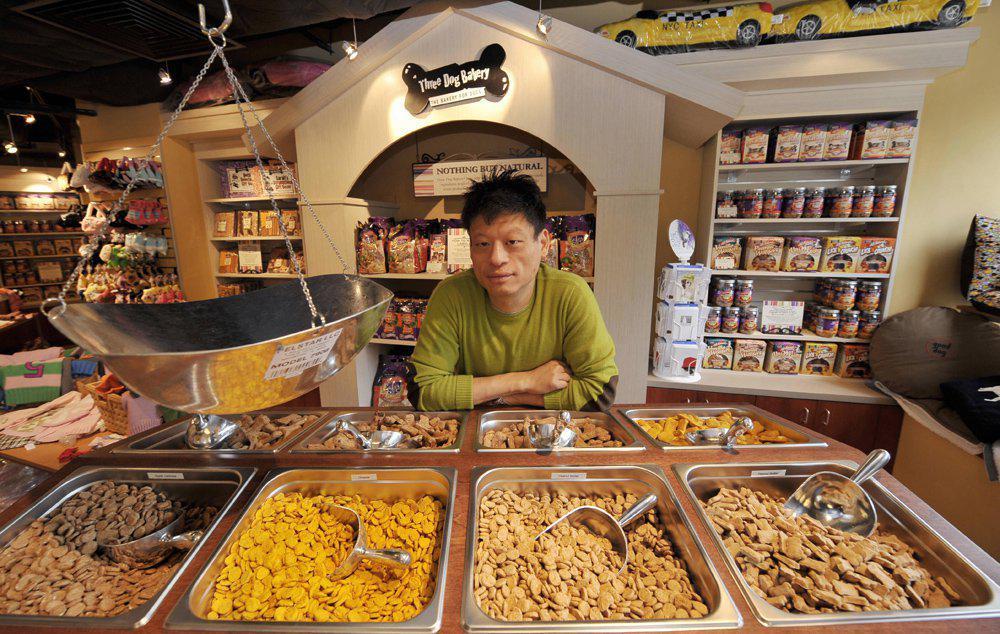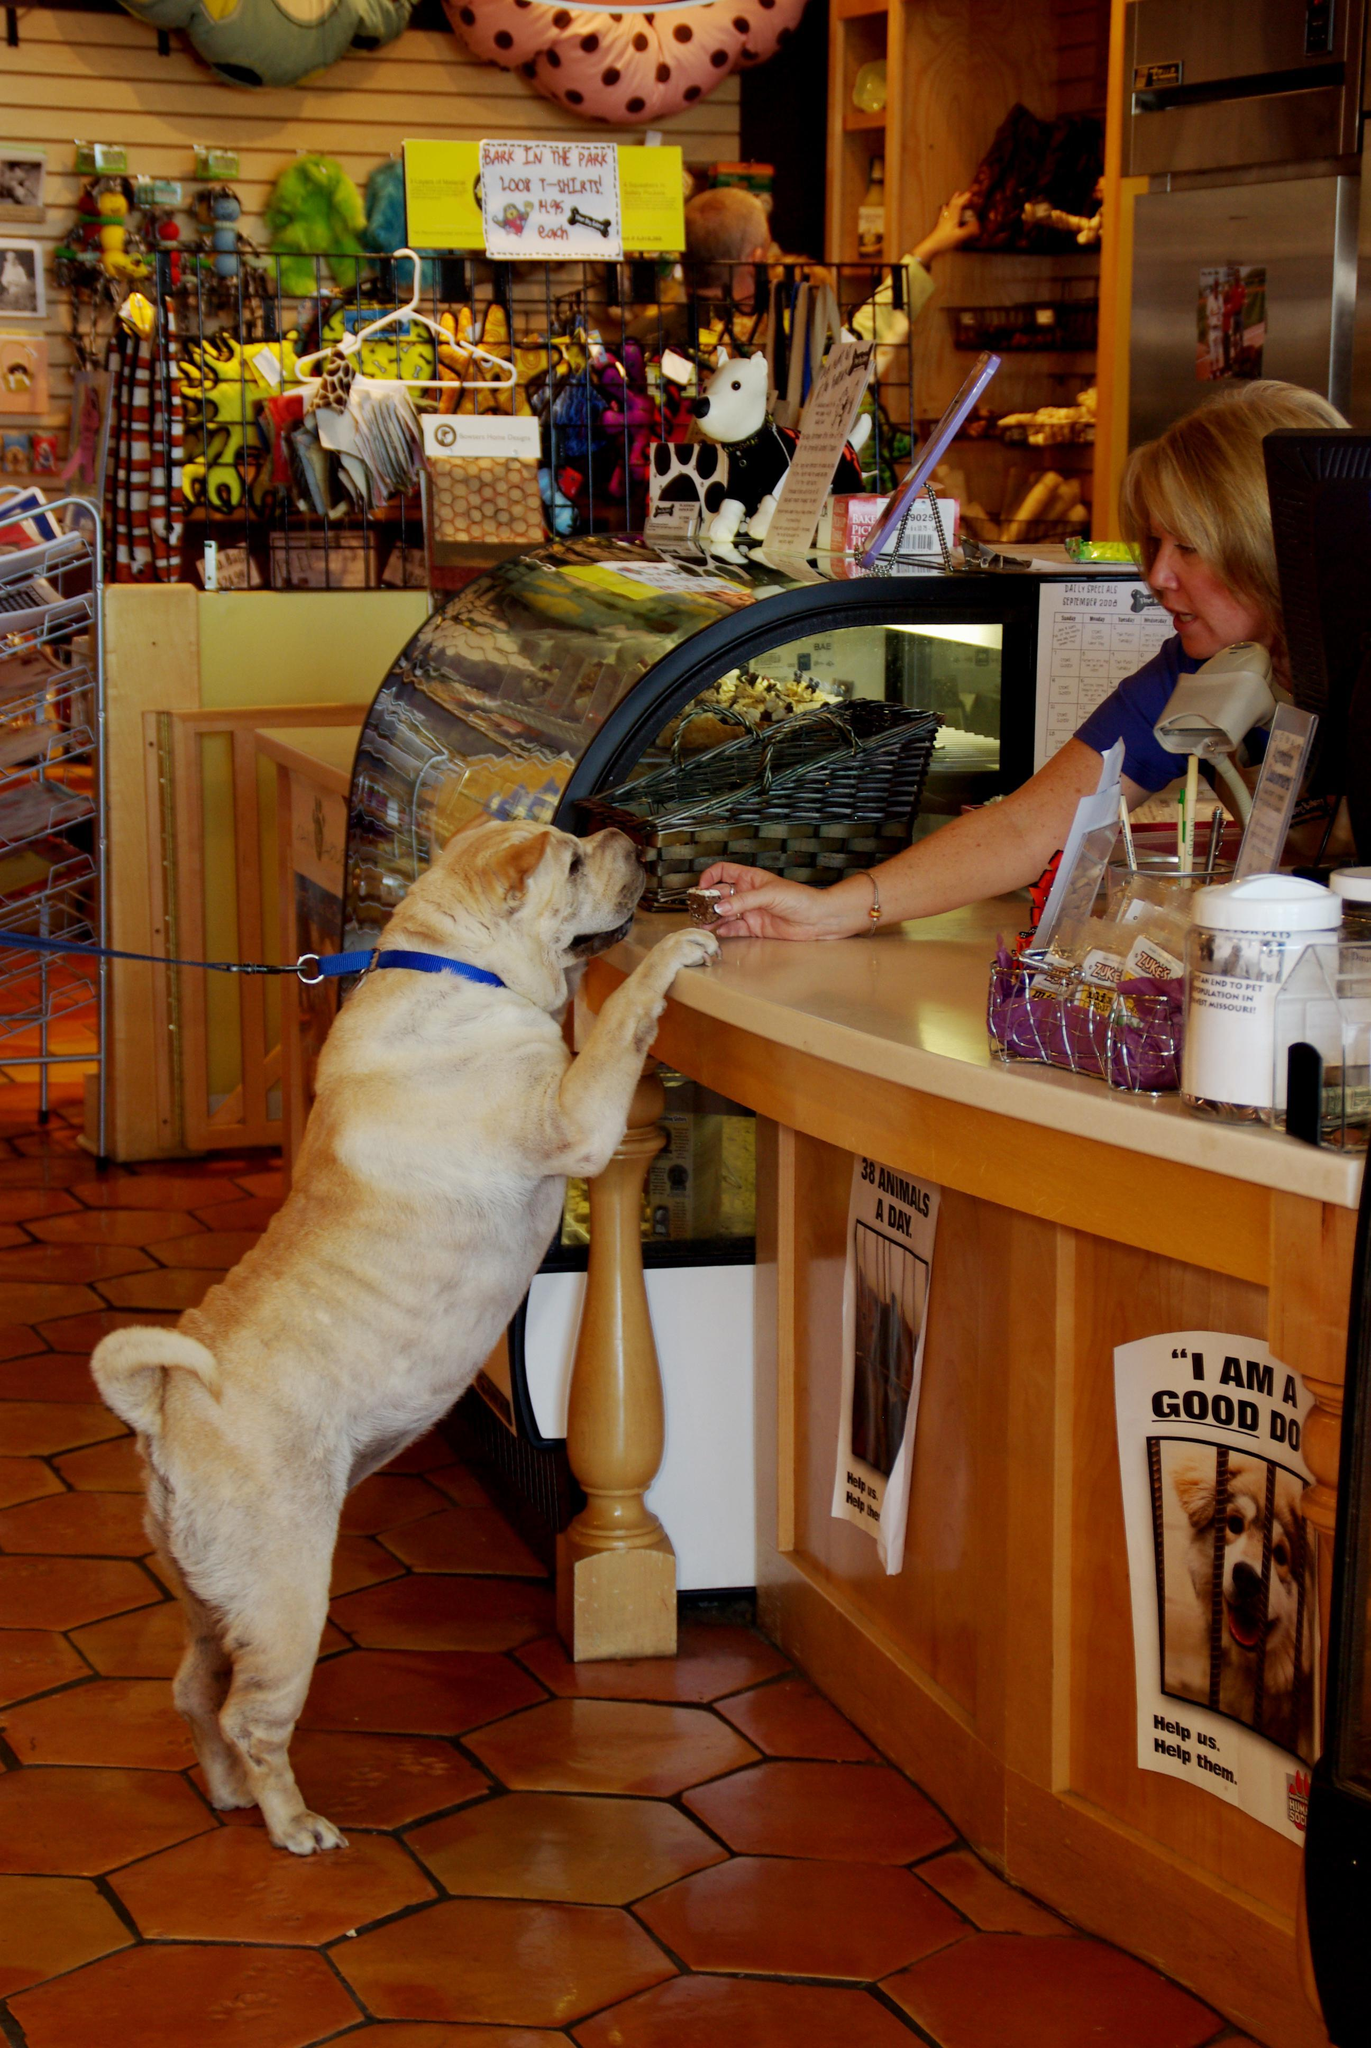The first image is the image on the left, the second image is the image on the right. Assess this claim about the two images: "An image shows a golden-haired right-facing dog standing with its front paws propped atop a wood-front counter.". Correct or not? Answer yes or no. Yes. The first image is the image on the left, the second image is the image on the right. For the images displayed, is the sentence "A dog has its front paws on the counter in the image on the right." factually correct? Answer yes or no. Yes. 